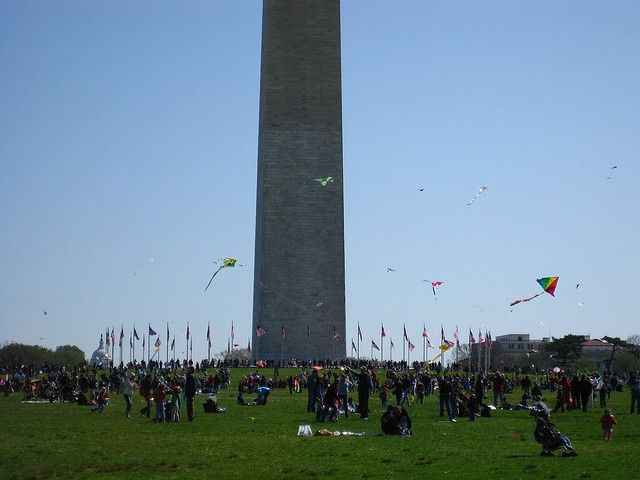Describe the objects in this image and their specific colors. I can see people in gray, black, and darkgreen tones, kite in gray, black, lightblue, and darkgray tones, people in gray, black, and darkgreen tones, people in gray, black, darkgreen, and navy tones, and people in gray, black, navy, and darkblue tones in this image. 